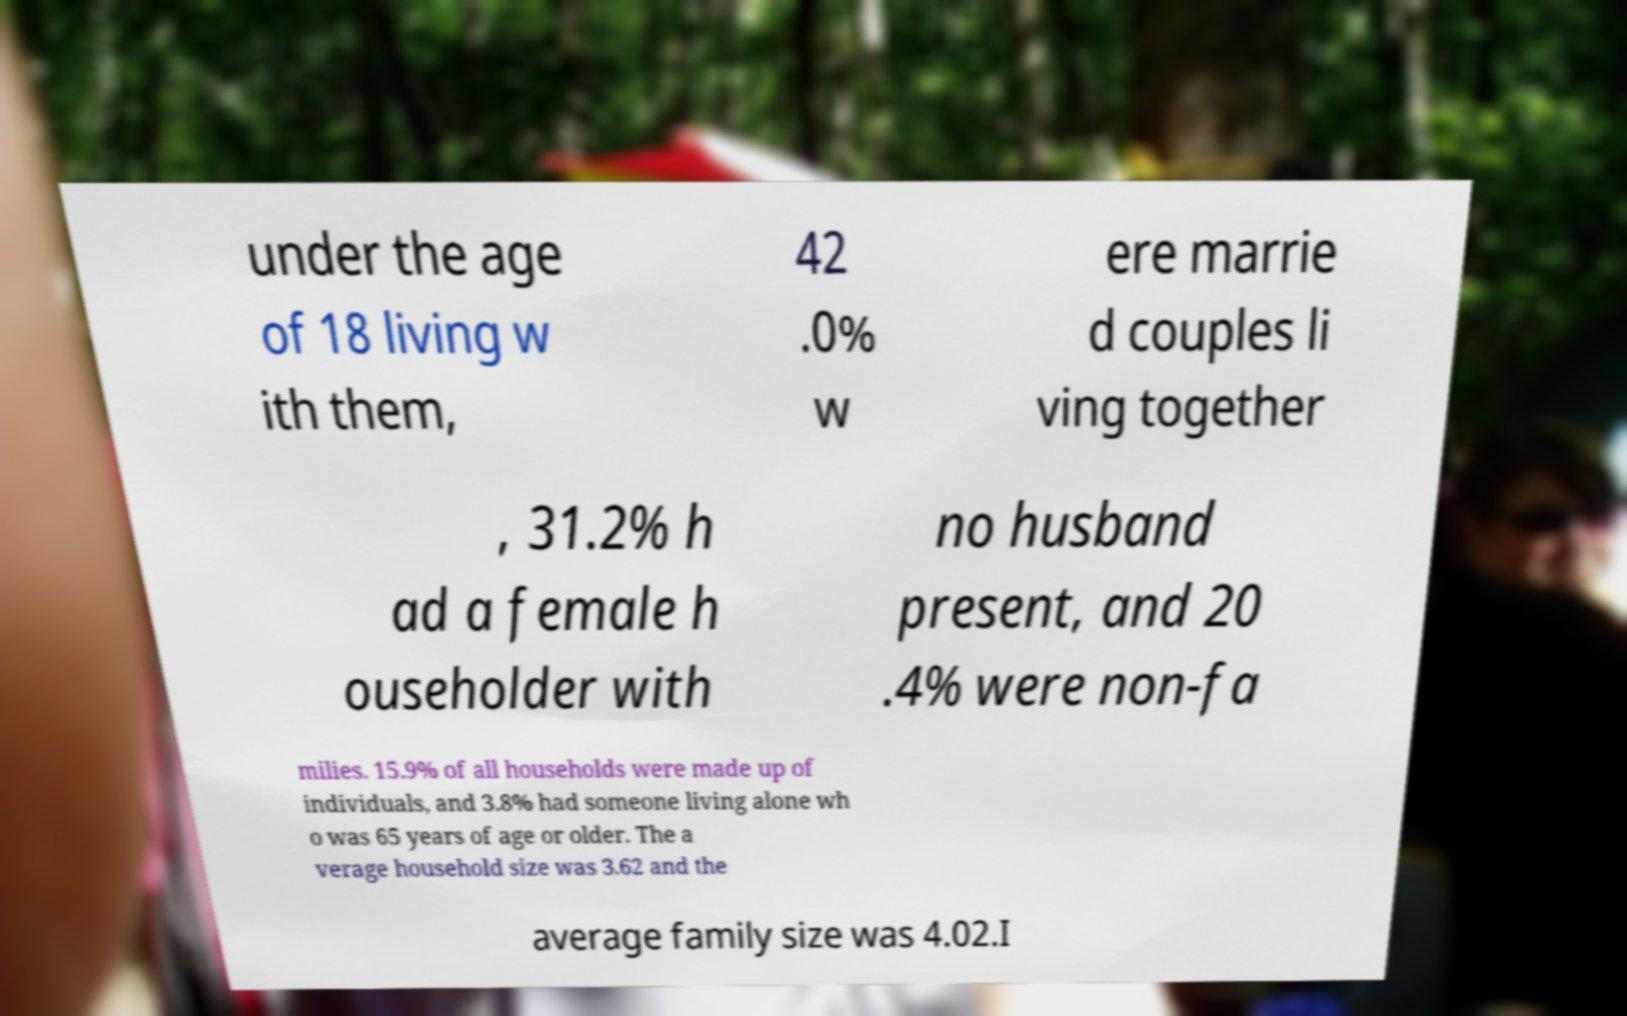Can you accurately transcribe the text from the provided image for me? under the age of 18 living w ith them, 42 .0% w ere marrie d couples li ving together , 31.2% h ad a female h ouseholder with no husband present, and 20 .4% were non-fa milies. 15.9% of all households were made up of individuals, and 3.8% had someone living alone wh o was 65 years of age or older. The a verage household size was 3.62 and the average family size was 4.02.I 